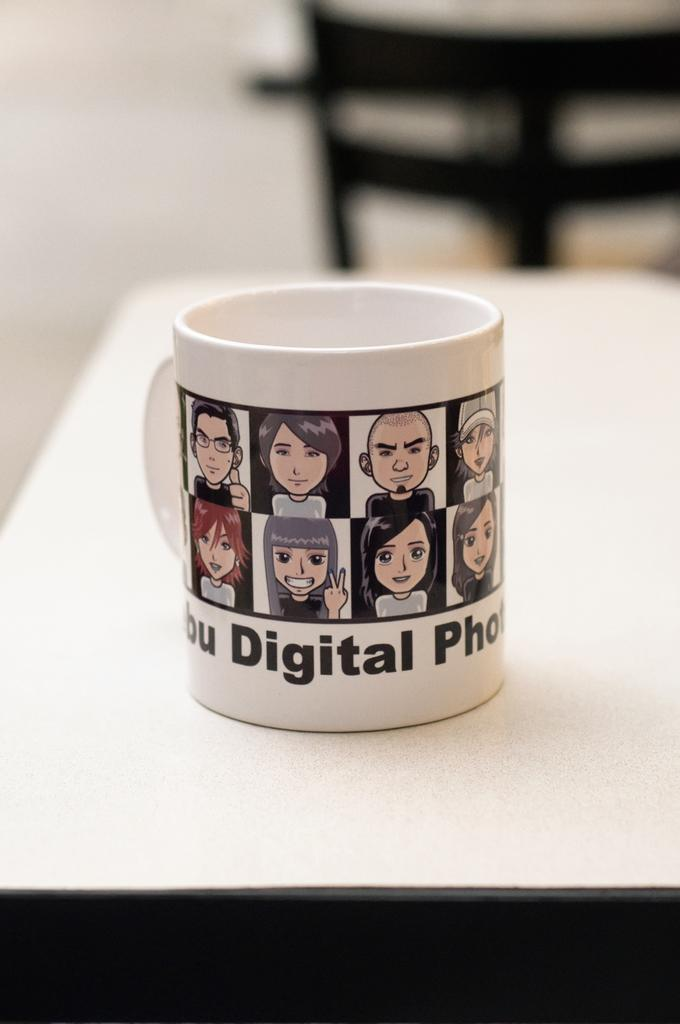Provide a one-sentence caption for the provided image. A mug with some anime faces on it that says digital photo. 